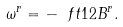Convert formula to latex. <formula><loc_0><loc_0><loc_500><loc_500>\omega ^ { r } = - \ f t 1 2 B ^ { r } .</formula> 